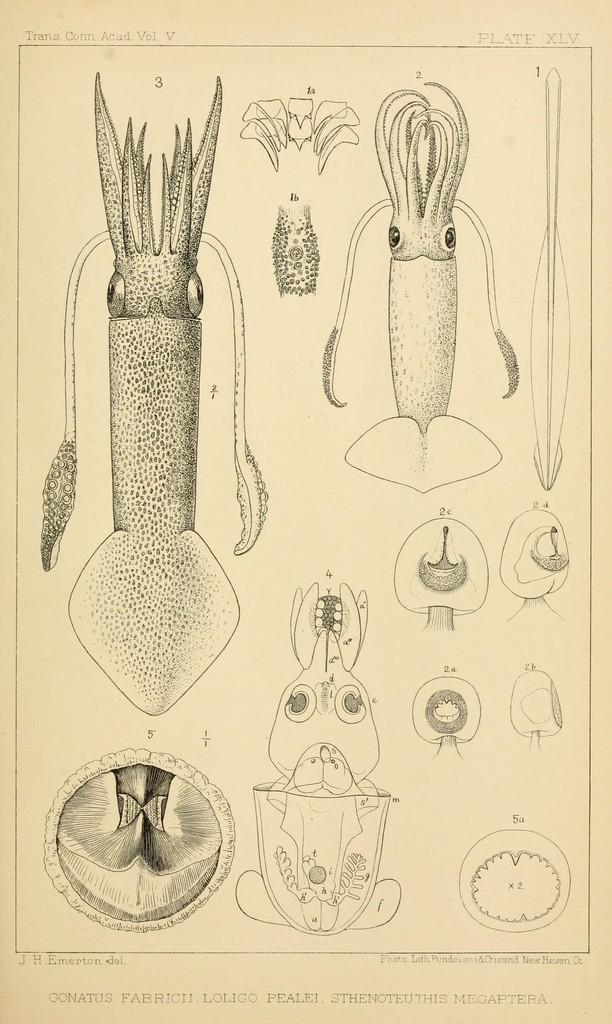What type of animals are depicted in the sketch in the image? The sketch in the image contains reptiles. What type of drain is visible in the image? There is no drain present in the image; it contains a sketch of reptiles. What color are the trousers worn by the reptiles in the image? Reptiles do not wear trousers, and there are no trousers visible in the image. 